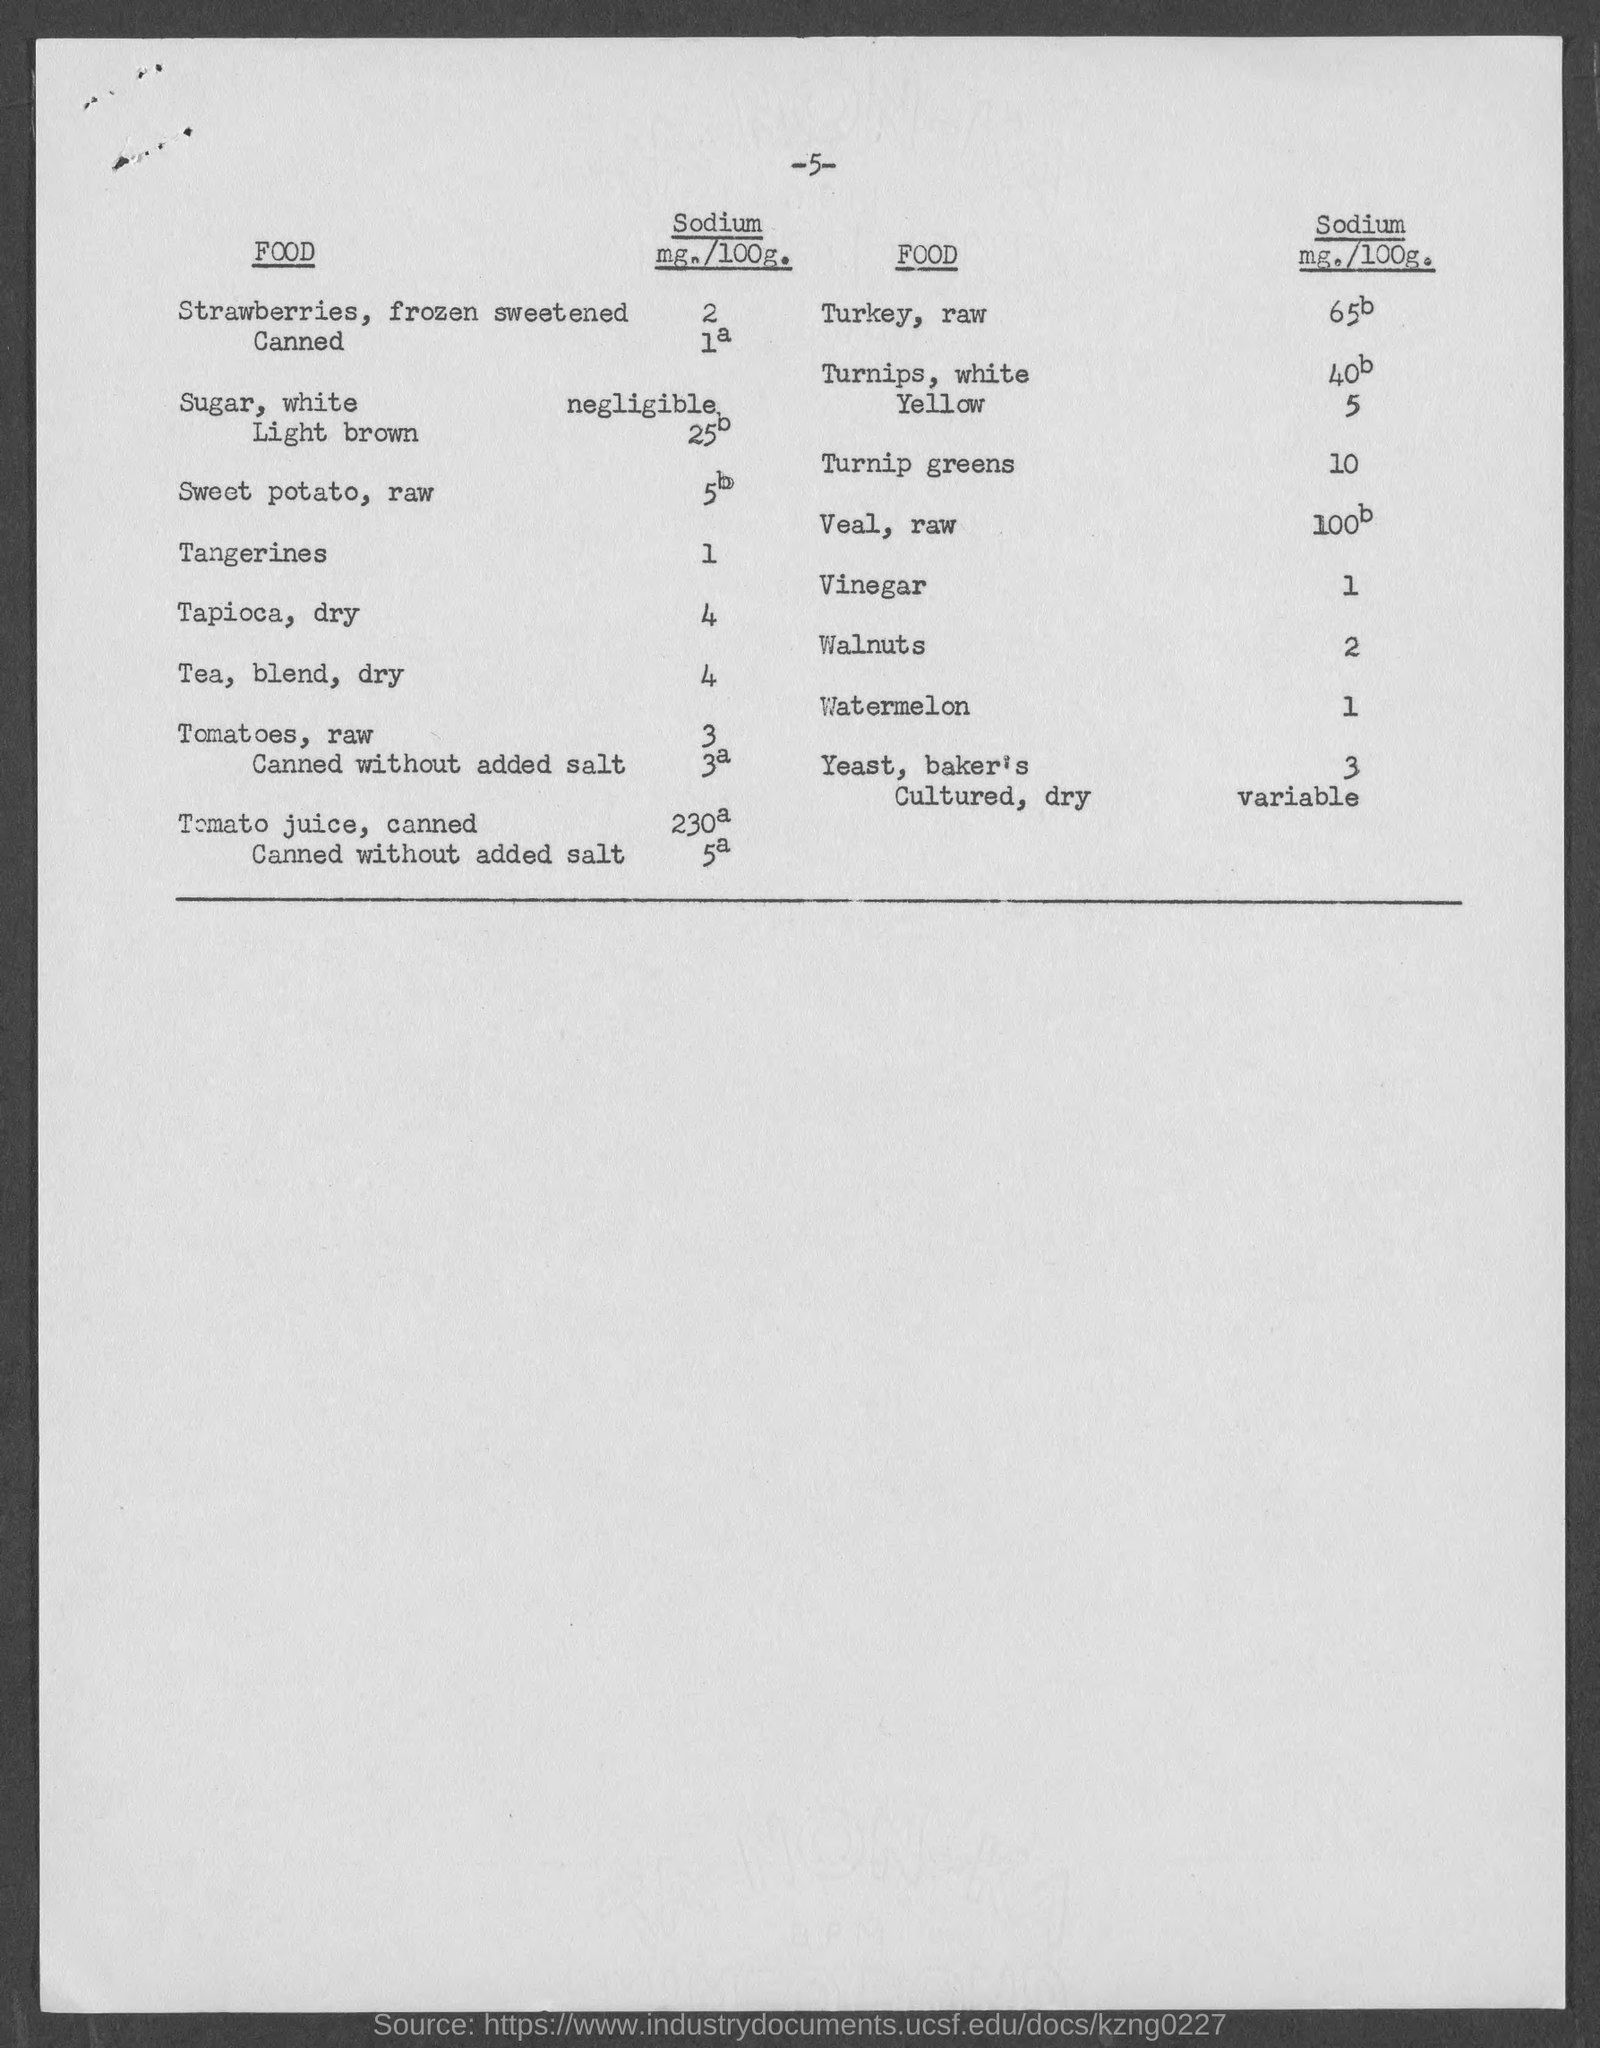What is the amount of sodium present in turnip greens ?
Keep it short and to the point. 10. What is the amount of sodium present in vinegar ?
Keep it short and to the point. 1. What is the amount of sodium present in walnuts ?
Offer a terse response. 2. What is the amount of sodium present in watermelon ?
Ensure brevity in your answer.  1. What is the amount of sodium present in tangerines ?
Offer a very short reply. 1. What is the amount of sodium present in tapioca,dry ?
Your answer should be very brief. 4. What is the amount of sodium present in tea , blend, dry ?
Ensure brevity in your answer.  4. What is the amount of sodium present in tomatoes,raw ?
Make the answer very short. 3. 